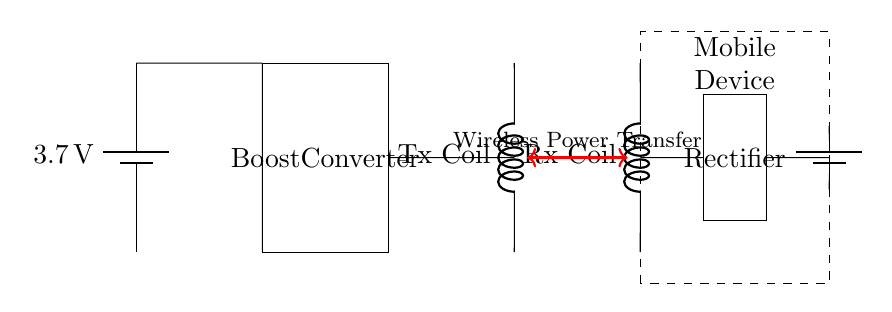What is the voltage of the battery? The battery in the circuit is labeled with a voltage of 3.7 volts, indicating the potential difference it provides.
Answer: 3.7 volts What type of converter is used in the circuit? The circuit features a boost converter, which is designed to increase the voltage from the battery to a higher voltage suitable for wireless charging.
Answer: Boost converter What is the purpose of the wireless charging coil? The wireless charging coil, labeled as the Tx coil, is used to transfer power wirelessly to the Rx coil in the mobile device, facilitating charging without physical connections.
Answer: Power transfer How many coils are in this circuit? The circuit includes two coils: a transmitting coil (Tx Coil) and a receiving coil (Rx Coil), which work together for wireless energy transfer.
Answer: Two coils What is the function of the rectifier in the circuit? The rectifier converts the alternating current produced by the wireless charging process into direct current, which is necessary for charging the battery within the mobile device.
Answer: Convert AC to DC Which component receives power wirelessly? The Rx coil located in the mobile device is responsible for receiving power wirelessly from the Tx coil through inductive coupling during the charging process.
Answer: Rx coil What feedback mechanism is indicated in the diagram? The red double-headed arrow in the diagram represents the wireless power transfer between the transmitting coil and the receiving coil, showing the feedback loop of the energy flow.
Answer: Wireless power transfer 